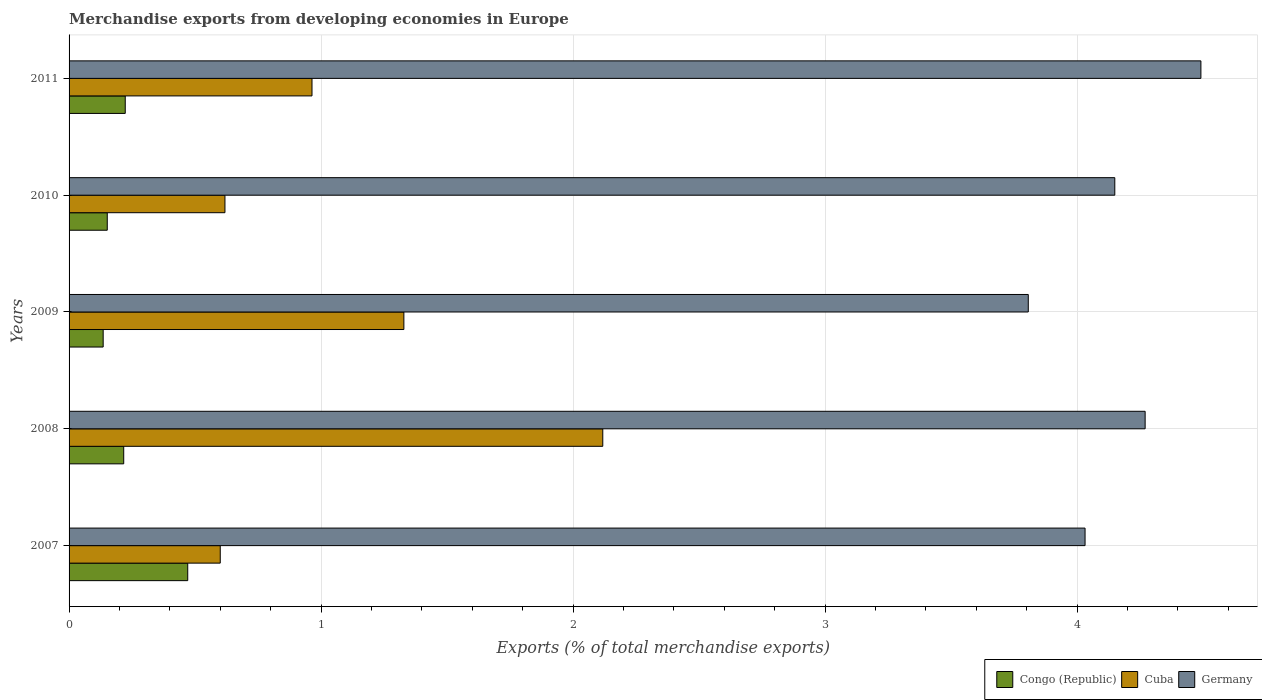How many groups of bars are there?
Offer a terse response. 5. Are the number of bars per tick equal to the number of legend labels?
Your answer should be compact. Yes. Are the number of bars on each tick of the Y-axis equal?
Offer a very short reply. Yes. How many bars are there on the 2nd tick from the bottom?
Ensure brevity in your answer.  3. What is the label of the 4th group of bars from the top?
Ensure brevity in your answer.  2008. In how many cases, is the number of bars for a given year not equal to the number of legend labels?
Provide a succinct answer. 0. What is the percentage of total merchandise exports in Germany in 2008?
Offer a very short reply. 4.27. Across all years, what is the maximum percentage of total merchandise exports in Congo (Republic)?
Give a very brief answer. 0.47. Across all years, what is the minimum percentage of total merchandise exports in Germany?
Ensure brevity in your answer.  3.81. In which year was the percentage of total merchandise exports in Congo (Republic) maximum?
Offer a terse response. 2007. In which year was the percentage of total merchandise exports in Cuba minimum?
Your answer should be compact. 2007. What is the total percentage of total merchandise exports in Cuba in the graph?
Your answer should be compact. 5.63. What is the difference between the percentage of total merchandise exports in Germany in 2009 and that in 2011?
Give a very brief answer. -0.69. What is the difference between the percentage of total merchandise exports in Germany in 2010 and the percentage of total merchandise exports in Congo (Republic) in 2011?
Provide a succinct answer. 3.93. What is the average percentage of total merchandise exports in Cuba per year?
Keep it short and to the point. 1.13. In the year 2011, what is the difference between the percentage of total merchandise exports in Germany and percentage of total merchandise exports in Congo (Republic)?
Give a very brief answer. 4.27. What is the ratio of the percentage of total merchandise exports in Congo (Republic) in 2008 to that in 2009?
Your answer should be compact. 1.6. What is the difference between the highest and the second highest percentage of total merchandise exports in Congo (Republic)?
Your response must be concise. 0.25. What is the difference between the highest and the lowest percentage of total merchandise exports in Cuba?
Keep it short and to the point. 1.52. Is the sum of the percentage of total merchandise exports in Cuba in 2010 and 2011 greater than the maximum percentage of total merchandise exports in Germany across all years?
Your response must be concise. No. What does the 2nd bar from the top in 2008 represents?
Make the answer very short. Cuba. What does the 1st bar from the bottom in 2010 represents?
Offer a very short reply. Congo (Republic). Is it the case that in every year, the sum of the percentage of total merchandise exports in Congo (Republic) and percentage of total merchandise exports in Cuba is greater than the percentage of total merchandise exports in Germany?
Make the answer very short. No. How many bars are there?
Your response must be concise. 15. Are all the bars in the graph horizontal?
Your response must be concise. Yes. Are the values on the major ticks of X-axis written in scientific E-notation?
Offer a terse response. No. Does the graph contain grids?
Ensure brevity in your answer.  Yes. Where does the legend appear in the graph?
Offer a very short reply. Bottom right. How many legend labels are there?
Offer a very short reply. 3. How are the legend labels stacked?
Your response must be concise. Horizontal. What is the title of the graph?
Keep it short and to the point. Merchandise exports from developing economies in Europe. Does "Azerbaijan" appear as one of the legend labels in the graph?
Give a very brief answer. No. What is the label or title of the X-axis?
Ensure brevity in your answer.  Exports (% of total merchandise exports). What is the label or title of the Y-axis?
Offer a very short reply. Years. What is the Exports (% of total merchandise exports) in Congo (Republic) in 2007?
Your answer should be compact. 0.47. What is the Exports (% of total merchandise exports) of Cuba in 2007?
Your response must be concise. 0.6. What is the Exports (% of total merchandise exports) of Germany in 2007?
Offer a terse response. 4.03. What is the Exports (% of total merchandise exports) in Congo (Republic) in 2008?
Your response must be concise. 0.22. What is the Exports (% of total merchandise exports) in Cuba in 2008?
Ensure brevity in your answer.  2.12. What is the Exports (% of total merchandise exports) of Germany in 2008?
Make the answer very short. 4.27. What is the Exports (% of total merchandise exports) of Congo (Republic) in 2009?
Give a very brief answer. 0.14. What is the Exports (% of total merchandise exports) in Cuba in 2009?
Your answer should be very brief. 1.33. What is the Exports (% of total merchandise exports) of Germany in 2009?
Your answer should be compact. 3.81. What is the Exports (% of total merchandise exports) in Congo (Republic) in 2010?
Give a very brief answer. 0.15. What is the Exports (% of total merchandise exports) in Cuba in 2010?
Provide a succinct answer. 0.62. What is the Exports (% of total merchandise exports) in Germany in 2010?
Keep it short and to the point. 4.15. What is the Exports (% of total merchandise exports) in Congo (Republic) in 2011?
Make the answer very short. 0.22. What is the Exports (% of total merchandise exports) in Cuba in 2011?
Your answer should be compact. 0.96. What is the Exports (% of total merchandise exports) in Germany in 2011?
Provide a short and direct response. 4.49. Across all years, what is the maximum Exports (% of total merchandise exports) of Congo (Republic)?
Make the answer very short. 0.47. Across all years, what is the maximum Exports (% of total merchandise exports) in Cuba?
Provide a short and direct response. 2.12. Across all years, what is the maximum Exports (% of total merchandise exports) of Germany?
Make the answer very short. 4.49. Across all years, what is the minimum Exports (% of total merchandise exports) of Congo (Republic)?
Your answer should be very brief. 0.14. Across all years, what is the minimum Exports (% of total merchandise exports) in Cuba?
Your answer should be compact. 0.6. Across all years, what is the minimum Exports (% of total merchandise exports) of Germany?
Your answer should be compact. 3.81. What is the total Exports (% of total merchandise exports) of Congo (Republic) in the graph?
Your answer should be very brief. 1.2. What is the total Exports (% of total merchandise exports) of Cuba in the graph?
Give a very brief answer. 5.63. What is the total Exports (% of total merchandise exports) of Germany in the graph?
Your answer should be compact. 20.75. What is the difference between the Exports (% of total merchandise exports) in Congo (Republic) in 2007 and that in 2008?
Offer a very short reply. 0.25. What is the difference between the Exports (% of total merchandise exports) of Cuba in 2007 and that in 2008?
Provide a short and direct response. -1.52. What is the difference between the Exports (% of total merchandise exports) in Germany in 2007 and that in 2008?
Ensure brevity in your answer.  -0.24. What is the difference between the Exports (% of total merchandise exports) in Congo (Republic) in 2007 and that in 2009?
Offer a very short reply. 0.34. What is the difference between the Exports (% of total merchandise exports) in Cuba in 2007 and that in 2009?
Your answer should be very brief. -0.73. What is the difference between the Exports (% of total merchandise exports) of Germany in 2007 and that in 2009?
Your answer should be very brief. 0.23. What is the difference between the Exports (% of total merchandise exports) in Congo (Republic) in 2007 and that in 2010?
Your answer should be compact. 0.32. What is the difference between the Exports (% of total merchandise exports) of Cuba in 2007 and that in 2010?
Provide a succinct answer. -0.02. What is the difference between the Exports (% of total merchandise exports) of Germany in 2007 and that in 2010?
Offer a terse response. -0.12. What is the difference between the Exports (% of total merchandise exports) in Congo (Republic) in 2007 and that in 2011?
Make the answer very short. 0.25. What is the difference between the Exports (% of total merchandise exports) of Cuba in 2007 and that in 2011?
Your response must be concise. -0.36. What is the difference between the Exports (% of total merchandise exports) in Germany in 2007 and that in 2011?
Offer a very short reply. -0.46. What is the difference between the Exports (% of total merchandise exports) of Congo (Republic) in 2008 and that in 2009?
Make the answer very short. 0.08. What is the difference between the Exports (% of total merchandise exports) of Cuba in 2008 and that in 2009?
Your response must be concise. 0.79. What is the difference between the Exports (% of total merchandise exports) of Germany in 2008 and that in 2009?
Make the answer very short. 0.46. What is the difference between the Exports (% of total merchandise exports) of Congo (Republic) in 2008 and that in 2010?
Make the answer very short. 0.07. What is the difference between the Exports (% of total merchandise exports) of Cuba in 2008 and that in 2010?
Give a very brief answer. 1.5. What is the difference between the Exports (% of total merchandise exports) of Germany in 2008 and that in 2010?
Provide a short and direct response. 0.12. What is the difference between the Exports (% of total merchandise exports) in Congo (Republic) in 2008 and that in 2011?
Give a very brief answer. -0.01. What is the difference between the Exports (% of total merchandise exports) of Cuba in 2008 and that in 2011?
Your answer should be very brief. 1.15. What is the difference between the Exports (% of total merchandise exports) in Germany in 2008 and that in 2011?
Your answer should be very brief. -0.22. What is the difference between the Exports (% of total merchandise exports) of Congo (Republic) in 2009 and that in 2010?
Offer a very short reply. -0.02. What is the difference between the Exports (% of total merchandise exports) of Cuba in 2009 and that in 2010?
Offer a very short reply. 0.71. What is the difference between the Exports (% of total merchandise exports) in Germany in 2009 and that in 2010?
Ensure brevity in your answer.  -0.34. What is the difference between the Exports (% of total merchandise exports) in Congo (Republic) in 2009 and that in 2011?
Provide a short and direct response. -0.09. What is the difference between the Exports (% of total merchandise exports) of Cuba in 2009 and that in 2011?
Your answer should be very brief. 0.36. What is the difference between the Exports (% of total merchandise exports) in Germany in 2009 and that in 2011?
Give a very brief answer. -0.69. What is the difference between the Exports (% of total merchandise exports) of Congo (Republic) in 2010 and that in 2011?
Ensure brevity in your answer.  -0.07. What is the difference between the Exports (% of total merchandise exports) of Cuba in 2010 and that in 2011?
Your answer should be very brief. -0.35. What is the difference between the Exports (% of total merchandise exports) of Germany in 2010 and that in 2011?
Make the answer very short. -0.34. What is the difference between the Exports (% of total merchandise exports) in Congo (Republic) in 2007 and the Exports (% of total merchandise exports) in Cuba in 2008?
Your response must be concise. -1.65. What is the difference between the Exports (% of total merchandise exports) in Congo (Republic) in 2007 and the Exports (% of total merchandise exports) in Germany in 2008?
Your response must be concise. -3.8. What is the difference between the Exports (% of total merchandise exports) in Cuba in 2007 and the Exports (% of total merchandise exports) in Germany in 2008?
Give a very brief answer. -3.67. What is the difference between the Exports (% of total merchandise exports) in Congo (Republic) in 2007 and the Exports (% of total merchandise exports) in Cuba in 2009?
Your answer should be very brief. -0.86. What is the difference between the Exports (% of total merchandise exports) of Congo (Republic) in 2007 and the Exports (% of total merchandise exports) of Germany in 2009?
Keep it short and to the point. -3.34. What is the difference between the Exports (% of total merchandise exports) of Cuba in 2007 and the Exports (% of total merchandise exports) of Germany in 2009?
Keep it short and to the point. -3.21. What is the difference between the Exports (% of total merchandise exports) of Congo (Republic) in 2007 and the Exports (% of total merchandise exports) of Cuba in 2010?
Keep it short and to the point. -0.15. What is the difference between the Exports (% of total merchandise exports) of Congo (Republic) in 2007 and the Exports (% of total merchandise exports) of Germany in 2010?
Provide a succinct answer. -3.68. What is the difference between the Exports (% of total merchandise exports) in Cuba in 2007 and the Exports (% of total merchandise exports) in Germany in 2010?
Offer a terse response. -3.55. What is the difference between the Exports (% of total merchandise exports) of Congo (Republic) in 2007 and the Exports (% of total merchandise exports) of Cuba in 2011?
Ensure brevity in your answer.  -0.49. What is the difference between the Exports (% of total merchandise exports) of Congo (Republic) in 2007 and the Exports (% of total merchandise exports) of Germany in 2011?
Your answer should be very brief. -4.02. What is the difference between the Exports (% of total merchandise exports) in Cuba in 2007 and the Exports (% of total merchandise exports) in Germany in 2011?
Your answer should be very brief. -3.89. What is the difference between the Exports (% of total merchandise exports) of Congo (Republic) in 2008 and the Exports (% of total merchandise exports) of Cuba in 2009?
Provide a succinct answer. -1.11. What is the difference between the Exports (% of total merchandise exports) of Congo (Republic) in 2008 and the Exports (% of total merchandise exports) of Germany in 2009?
Your response must be concise. -3.59. What is the difference between the Exports (% of total merchandise exports) of Cuba in 2008 and the Exports (% of total merchandise exports) of Germany in 2009?
Make the answer very short. -1.69. What is the difference between the Exports (% of total merchandise exports) of Congo (Republic) in 2008 and the Exports (% of total merchandise exports) of Cuba in 2010?
Your response must be concise. -0.4. What is the difference between the Exports (% of total merchandise exports) of Congo (Republic) in 2008 and the Exports (% of total merchandise exports) of Germany in 2010?
Provide a succinct answer. -3.93. What is the difference between the Exports (% of total merchandise exports) of Cuba in 2008 and the Exports (% of total merchandise exports) of Germany in 2010?
Ensure brevity in your answer.  -2.03. What is the difference between the Exports (% of total merchandise exports) of Congo (Republic) in 2008 and the Exports (% of total merchandise exports) of Cuba in 2011?
Provide a short and direct response. -0.75. What is the difference between the Exports (% of total merchandise exports) of Congo (Republic) in 2008 and the Exports (% of total merchandise exports) of Germany in 2011?
Your answer should be compact. -4.27. What is the difference between the Exports (% of total merchandise exports) in Cuba in 2008 and the Exports (% of total merchandise exports) in Germany in 2011?
Your response must be concise. -2.37. What is the difference between the Exports (% of total merchandise exports) in Congo (Republic) in 2009 and the Exports (% of total merchandise exports) in Cuba in 2010?
Ensure brevity in your answer.  -0.48. What is the difference between the Exports (% of total merchandise exports) in Congo (Republic) in 2009 and the Exports (% of total merchandise exports) in Germany in 2010?
Keep it short and to the point. -4.01. What is the difference between the Exports (% of total merchandise exports) of Cuba in 2009 and the Exports (% of total merchandise exports) of Germany in 2010?
Your answer should be compact. -2.82. What is the difference between the Exports (% of total merchandise exports) of Congo (Republic) in 2009 and the Exports (% of total merchandise exports) of Cuba in 2011?
Provide a short and direct response. -0.83. What is the difference between the Exports (% of total merchandise exports) of Congo (Republic) in 2009 and the Exports (% of total merchandise exports) of Germany in 2011?
Make the answer very short. -4.36. What is the difference between the Exports (% of total merchandise exports) in Cuba in 2009 and the Exports (% of total merchandise exports) in Germany in 2011?
Your response must be concise. -3.16. What is the difference between the Exports (% of total merchandise exports) in Congo (Republic) in 2010 and the Exports (% of total merchandise exports) in Cuba in 2011?
Keep it short and to the point. -0.81. What is the difference between the Exports (% of total merchandise exports) in Congo (Republic) in 2010 and the Exports (% of total merchandise exports) in Germany in 2011?
Provide a succinct answer. -4.34. What is the difference between the Exports (% of total merchandise exports) of Cuba in 2010 and the Exports (% of total merchandise exports) of Germany in 2011?
Keep it short and to the point. -3.87. What is the average Exports (% of total merchandise exports) of Congo (Republic) per year?
Give a very brief answer. 0.24. What is the average Exports (% of total merchandise exports) of Cuba per year?
Your answer should be very brief. 1.13. What is the average Exports (% of total merchandise exports) of Germany per year?
Offer a very short reply. 4.15. In the year 2007, what is the difference between the Exports (% of total merchandise exports) in Congo (Republic) and Exports (% of total merchandise exports) in Cuba?
Give a very brief answer. -0.13. In the year 2007, what is the difference between the Exports (% of total merchandise exports) of Congo (Republic) and Exports (% of total merchandise exports) of Germany?
Your answer should be very brief. -3.56. In the year 2007, what is the difference between the Exports (% of total merchandise exports) in Cuba and Exports (% of total merchandise exports) in Germany?
Keep it short and to the point. -3.43. In the year 2008, what is the difference between the Exports (% of total merchandise exports) in Congo (Republic) and Exports (% of total merchandise exports) in Cuba?
Keep it short and to the point. -1.9. In the year 2008, what is the difference between the Exports (% of total merchandise exports) in Congo (Republic) and Exports (% of total merchandise exports) in Germany?
Ensure brevity in your answer.  -4.05. In the year 2008, what is the difference between the Exports (% of total merchandise exports) in Cuba and Exports (% of total merchandise exports) in Germany?
Keep it short and to the point. -2.15. In the year 2009, what is the difference between the Exports (% of total merchandise exports) of Congo (Republic) and Exports (% of total merchandise exports) of Cuba?
Offer a very short reply. -1.19. In the year 2009, what is the difference between the Exports (% of total merchandise exports) of Congo (Republic) and Exports (% of total merchandise exports) of Germany?
Give a very brief answer. -3.67. In the year 2009, what is the difference between the Exports (% of total merchandise exports) of Cuba and Exports (% of total merchandise exports) of Germany?
Give a very brief answer. -2.48. In the year 2010, what is the difference between the Exports (% of total merchandise exports) of Congo (Republic) and Exports (% of total merchandise exports) of Cuba?
Provide a short and direct response. -0.47. In the year 2010, what is the difference between the Exports (% of total merchandise exports) in Congo (Republic) and Exports (% of total merchandise exports) in Germany?
Provide a succinct answer. -4. In the year 2010, what is the difference between the Exports (% of total merchandise exports) in Cuba and Exports (% of total merchandise exports) in Germany?
Offer a very short reply. -3.53. In the year 2011, what is the difference between the Exports (% of total merchandise exports) in Congo (Republic) and Exports (% of total merchandise exports) in Cuba?
Ensure brevity in your answer.  -0.74. In the year 2011, what is the difference between the Exports (% of total merchandise exports) of Congo (Republic) and Exports (% of total merchandise exports) of Germany?
Make the answer very short. -4.27. In the year 2011, what is the difference between the Exports (% of total merchandise exports) of Cuba and Exports (% of total merchandise exports) of Germany?
Your answer should be compact. -3.53. What is the ratio of the Exports (% of total merchandise exports) in Congo (Republic) in 2007 to that in 2008?
Provide a short and direct response. 2.17. What is the ratio of the Exports (% of total merchandise exports) in Cuba in 2007 to that in 2008?
Give a very brief answer. 0.28. What is the ratio of the Exports (% of total merchandise exports) of Germany in 2007 to that in 2008?
Your answer should be compact. 0.94. What is the ratio of the Exports (% of total merchandise exports) of Congo (Republic) in 2007 to that in 2009?
Your answer should be compact. 3.48. What is the ratio of the Exports (% of total merchandise exports) of Cuba in 2007 to that in 2009?
Give a very brief answer. 0.45. What is the ratio of the Exports (% of total merchandise exports) of Germany in 2007 to that in 2009?
Provide a succinct answer. 1.06. What is the ratio of the Exports (% of total merchandise exports) of Congo (Republic) in 2007 to that in 2010?
Your response must be concise. 3.11. What is the ratio of the Exports (% of total merchandise exports) in Cuba in 2007 to that in 2010?
Ensure brevity in your answer.  0.97. What is the ratio of the Exports (% of total merchandise exports) in Germany in 2007 to that in 2010?
Your response must be concise. 0.97. What is the ratio of the Exports (% of total merchandise exports) of Congo (Republic) in 2007 to that in 2011?
Keep it short and to the point. 2.11. What is the ratio of the Exports (% of total merchandise exports) of Cuba in 2007 to that in 2011?
Your answer should be compact. 0.62. What is the ratio of the Exports (% of total merchandise exports) in Germany in 2007 to that in 2011?
Your response must be concise. 0.9. What is the ratio of the Exports (% of total merchandise exports) in Congo (Republic) in 2008 to that in 2009?
Your response must be concise. 1.6. What is the ratio of the Exports (% of total merchandise exports) of Cuba in 2008 to that in 2009?
Your answer should be compact. 1.59. What is the ratio of the Exports (% of total merchandise exports) of Germany in 2008 to that in 2009?
Your answer should be compact. 1.12. What is the ratio of the Exports (% of total merchandise exports) of Congo (Republic) in 2008 to that in 2010?
Provide a short and direct response. 1.43. What is the ratio of the Exports (% of total merchandise exports) in Cuba in 2008 to that in 2010?
Your response must be concise. 3.42. What is the ratio of the Exports (% of total merchandise exports) in Congo (Republic) in 2008 to that in 2011?
Give a very brief answer. 0.97. What is the ratio of the Exports (% of total merchandise exports) in Cuba in 2008 to that in 2011?
Provide a succinct answer. 2.2. What is the ratio of the Exports (% of total merchandise exports) in Germany in 2008 to that in 2011?
Your response must be concise. 0.95. What is the ratio of the Exports (% of total merchandise exports) of Congo (Republic) in 2009 to that in 2010?
Offer a terse response. 0.89. What is the ratio of the Exports (% of total merchandise exports) in Cuba in 2009 to that in 2010?
Give a very brief answer. 2.15. What is the ratio of the Exports (% of total merchandise exports) in Germany in 2009 to that in 2010?
Offer a terse response. 0.92. What is the ratio of the Exports (% of total merchandise exports) in Congo (Republic) in 2009 to that in 2011?
Your answer should be compact. 0.61. What is the ratio of the Exports (% of total merchandise exports) of Cuba in 2009 to that in 2011?
Your answer should be compact. 1.38. What is the ratio of the Exports (% of total merchandise exports) of Germany in 2009 to that in 2011?
Your answer should be compact. 0.85. What is the ratio of the Exports (% of total merchandise exports) in Congo (Republic) in 2010 to that in 2011?
Offer a terse response. 0.68. What is the ratio of the Exports (% of total merchandise exports) of Cuba in 2010 to that in 2011?
Your answer should be very brief. 0.64. What is the ratio of the Exports (% of total merchandise exports) in Germany in 2010 to that in 2011?
Your answer should be very brief. 0.92. What is the difference between the highest and the second highest Exports (% of total merchandise exports) of Congo (Republic)?
Your answer should be compact. 0.25. What is the difference between the highest and the second highest Exports (% of total merchandise exports) of Cuba?
Provide a succinct answer. 0.79. What is the difference between the highest and the second highest Exports (% of total merchandise exports) of Germany?
Give a very brief answer. 0.22. What is the difference between the highest and the lowest Exports (% of total merchandise exports) in Congo (Republic)?
Provide a succinct answer. 0.34. What is the difference between the highest and the lowest Exports (% of total merchandise exports) of Cuba?
Offer a terse response. 1.52. What is the difference between the highest and the lowest Exports (% of total merchandise exports) of Germany?
Your response must be concise. 0.69. 